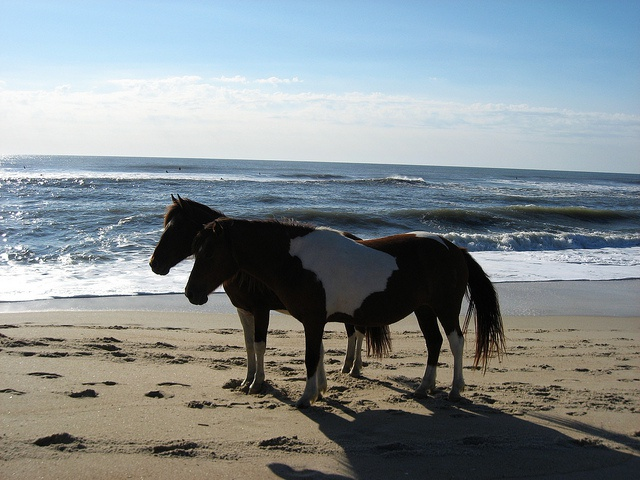Describe the objects in this image and their specific colors. I can see horse in lightblue, black, gray, and darkgray tones and horse in lightblue, black, and gray tones in this image. 